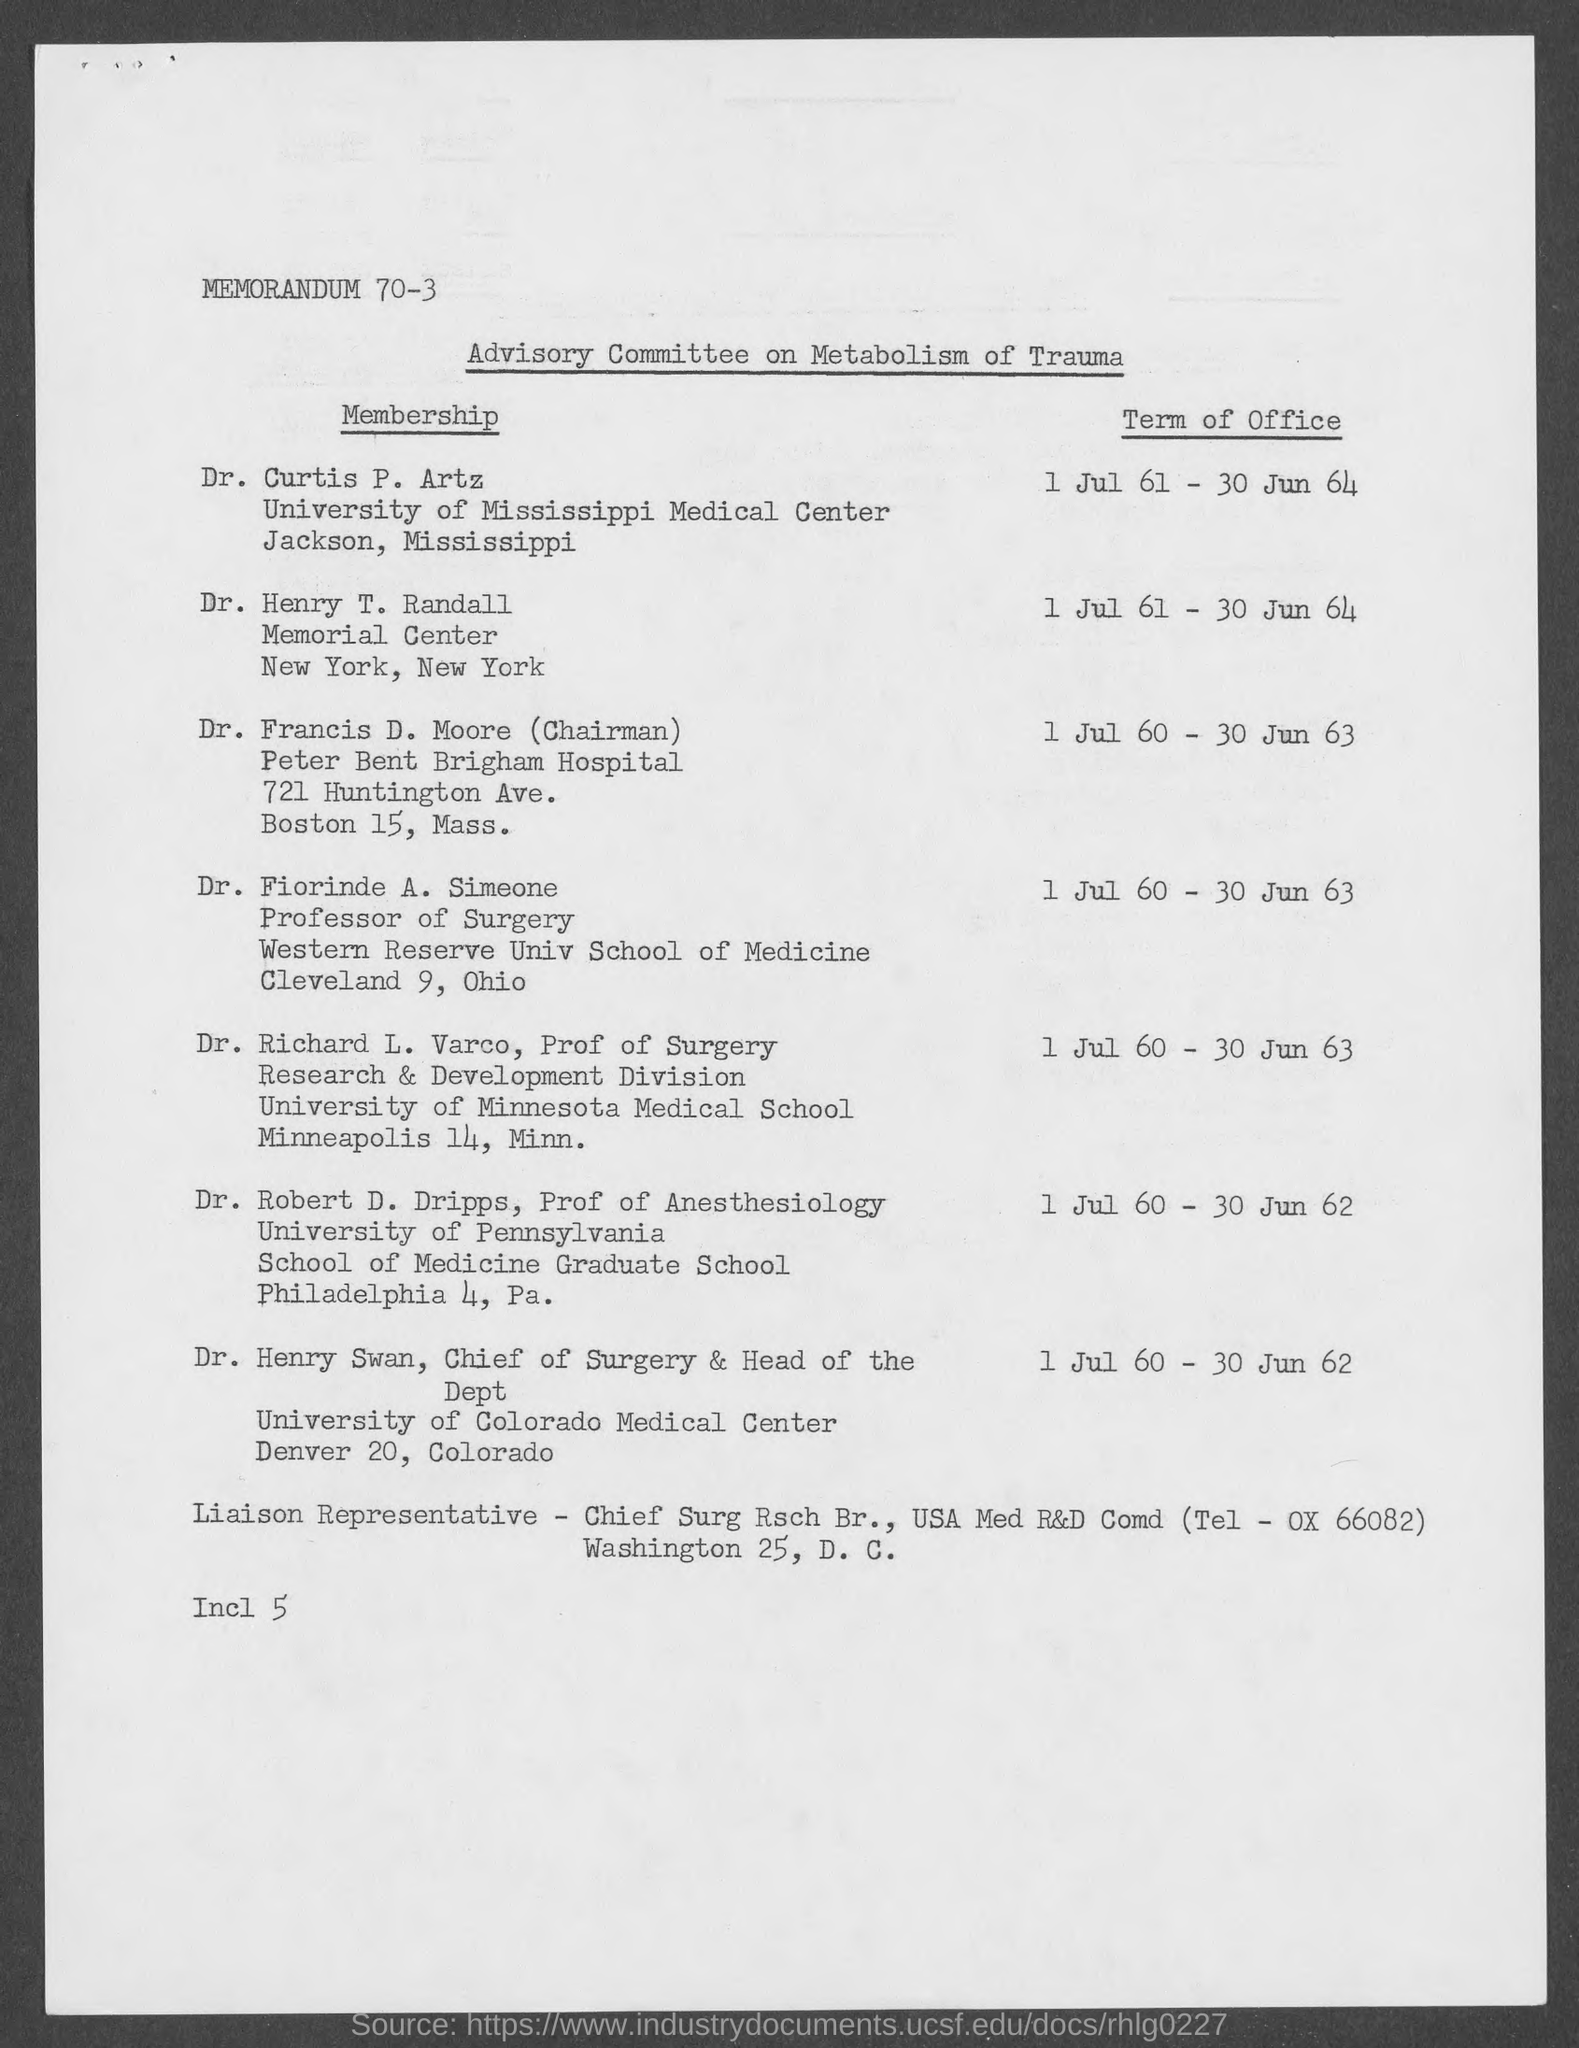Give some essential details in this illustration. Dr. Henry Swan belongs to the University of Colorado Medical Center. Dr. Fiorinde A. Simeone holds the position of Professor of Surgery. Dr. Curtis belongs to the University of Mississippi Medical Center. The memorandum number is 70-3. Dr. Robert D. Dripps belongs to the University of Pennsylvania. 